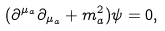Convert formula to latex. <formula><loc_0><loc_0><loc_500><loc_500>( \partial ^ { \mu _ { a } } \partial _ { \mu _ { a } } + m _ { a } ^ { 2 } ) \psi = 0 ,</formula> 